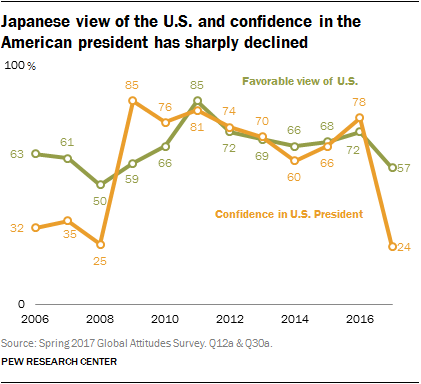Point out several critical features in this image. The average of the last 3 data values in the green line is 65.67. The orange line chart shows a trend of confidence in the U.S. President, with the value indicating a certain level of confidence. 